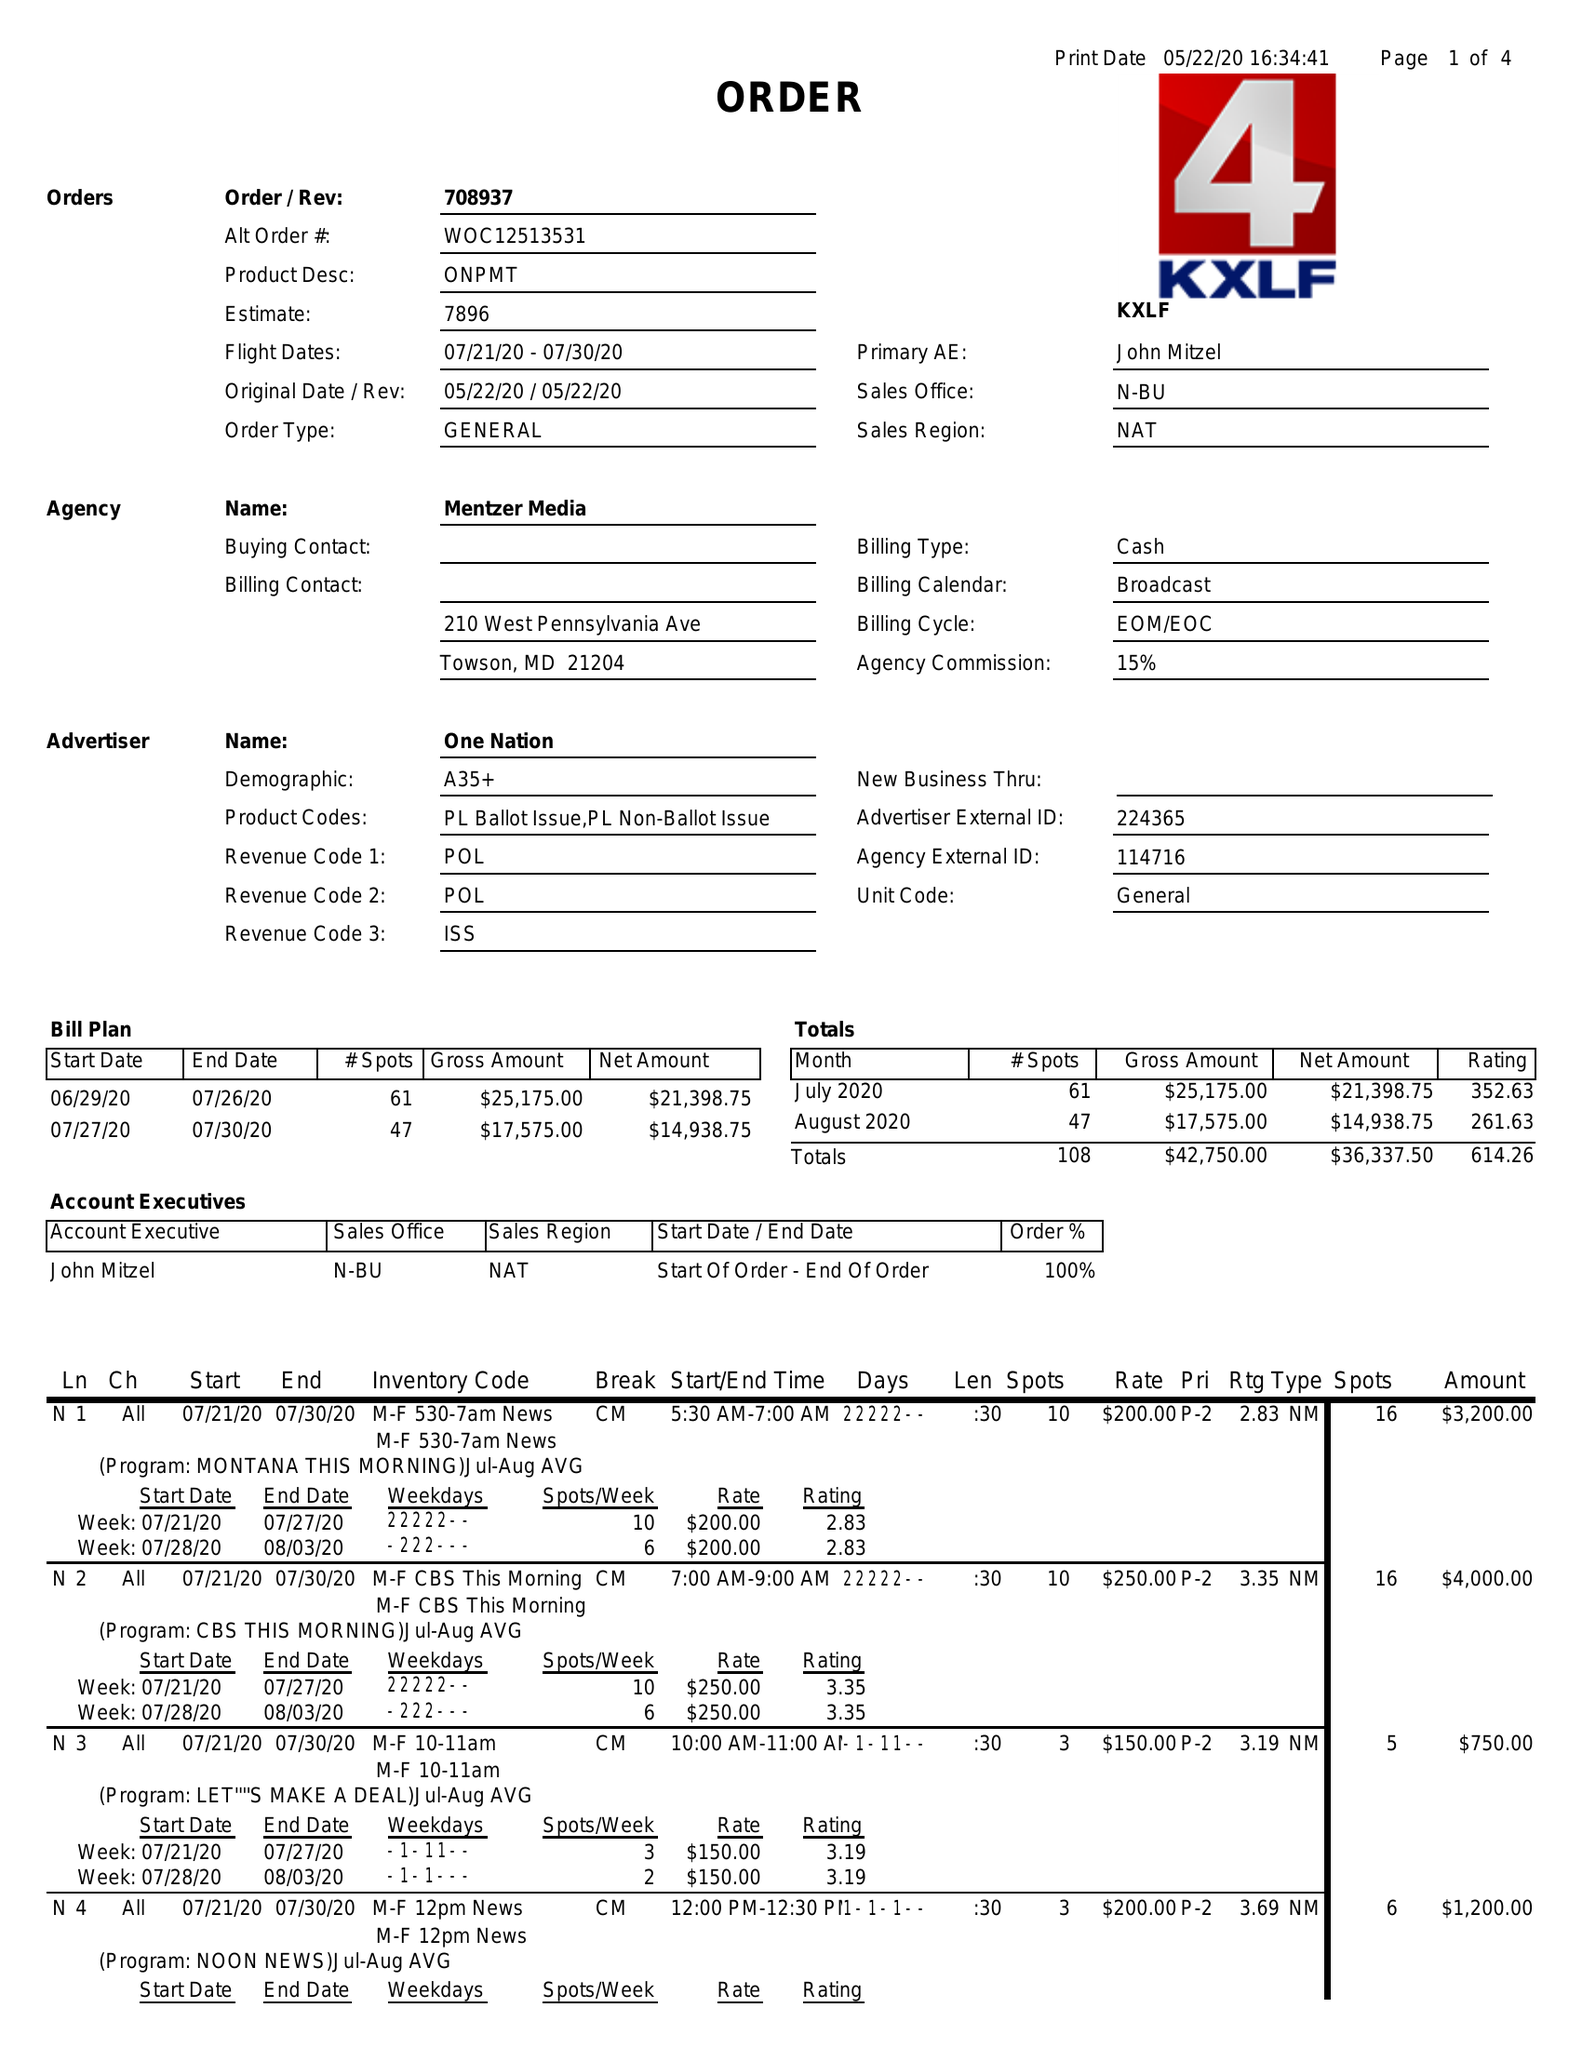What is the value for the flight_from?
Answer the question using a single word or phrase. 07/21/20 